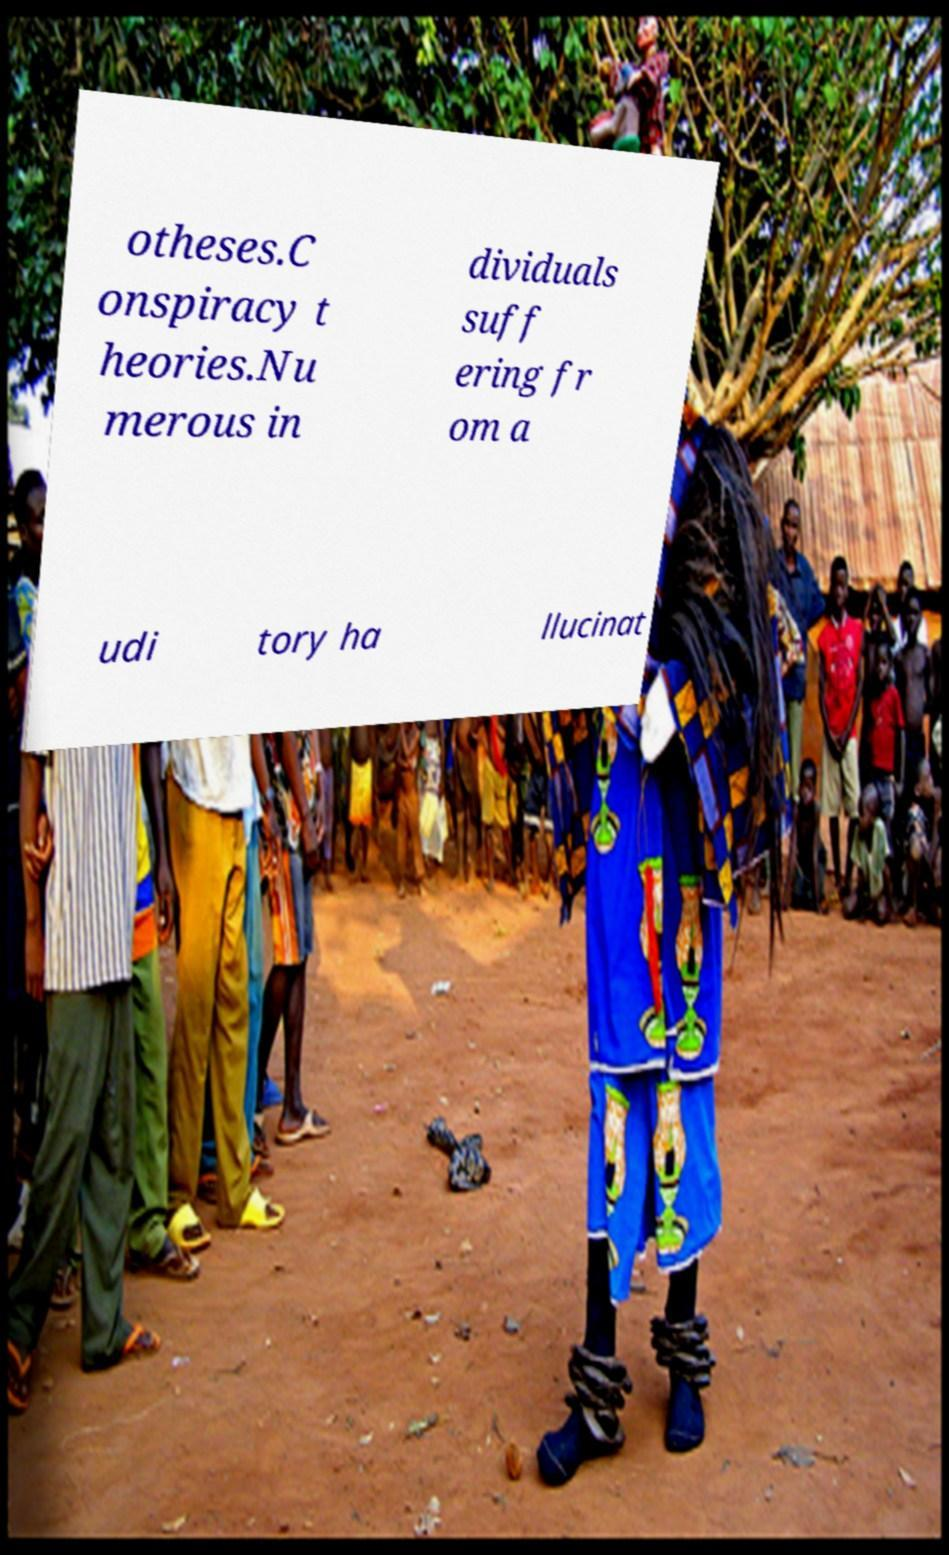I need the written content from this picture converted into text. Can you do that? otheses.C onspiracy t heories.Nu merous in dividuals suff ering fr om a udi tory ha llucinat 